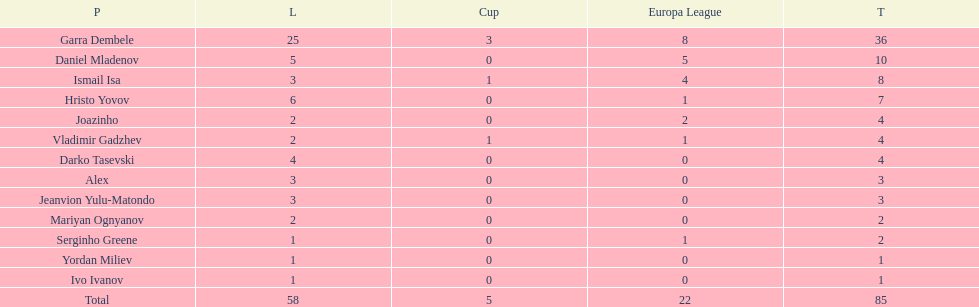Which player is in the same league as joazinho and vladimir gadzhev? Mariyan Ognyanov. 